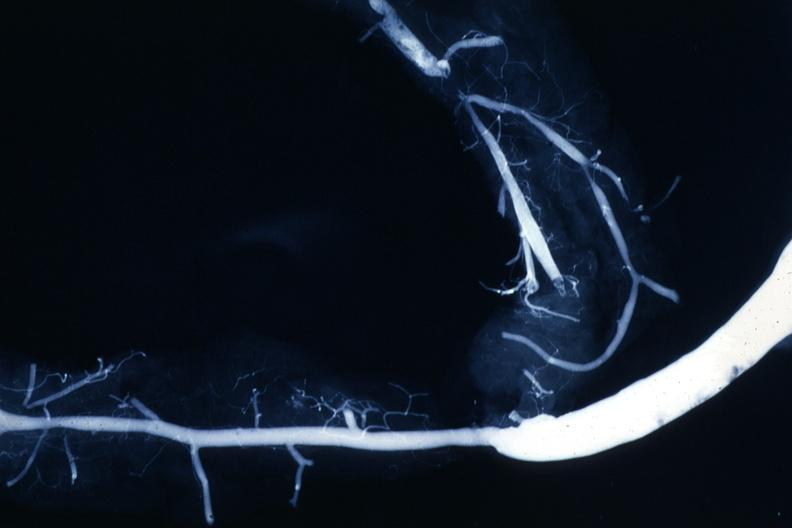what does this image show?
Answer the question using a single word or phrase. Shows rather close-up large vein anastomosing to much smaller artery 